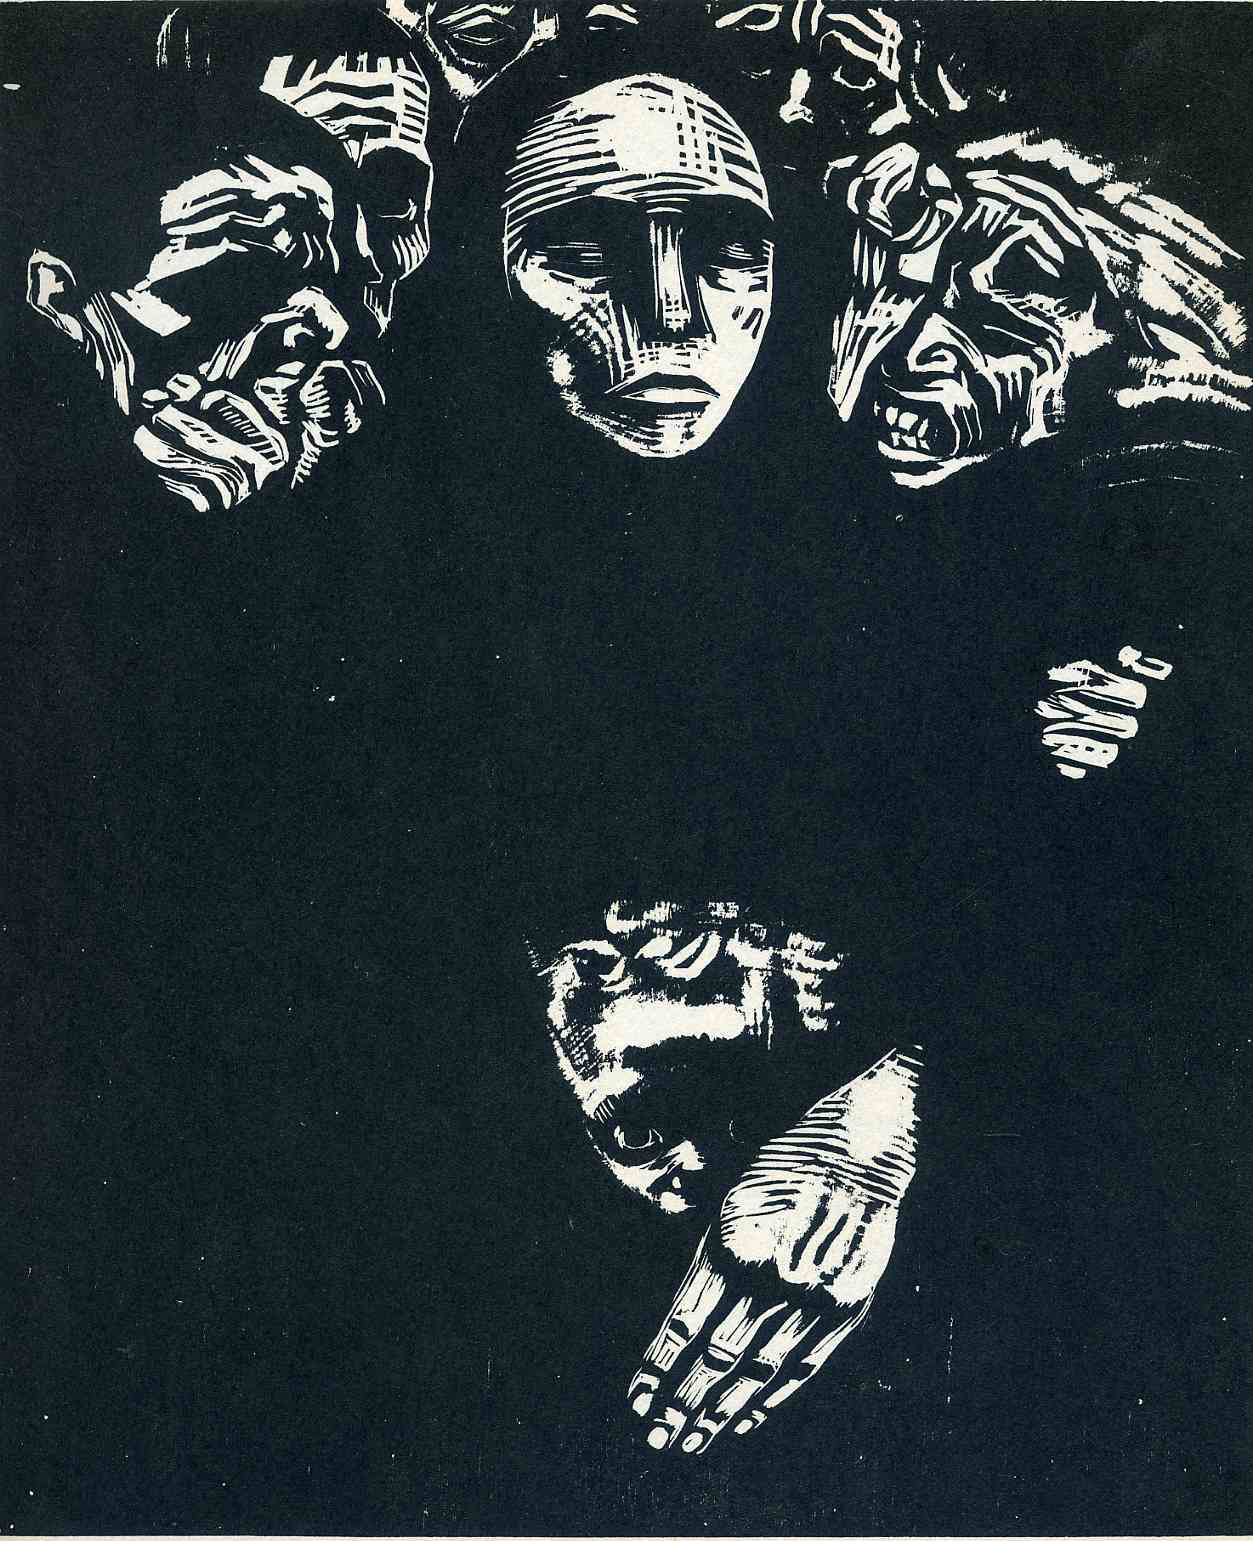Can you interpret the symbolism behind the hands reaching upwards in this image? The upward-reaching hands in the image symbolize a longing or striving for something greater, perhaps a reach for transcendence, understanding, or connection. They may also suggest a plea for help or an expression of vulnerability and the human condition. This gesture adds a dynamic layer to the artwork, presenting a tangible action in contrast to the passive, observing faces above, possibly alluding to the active pursuit of personal or collective goals. 